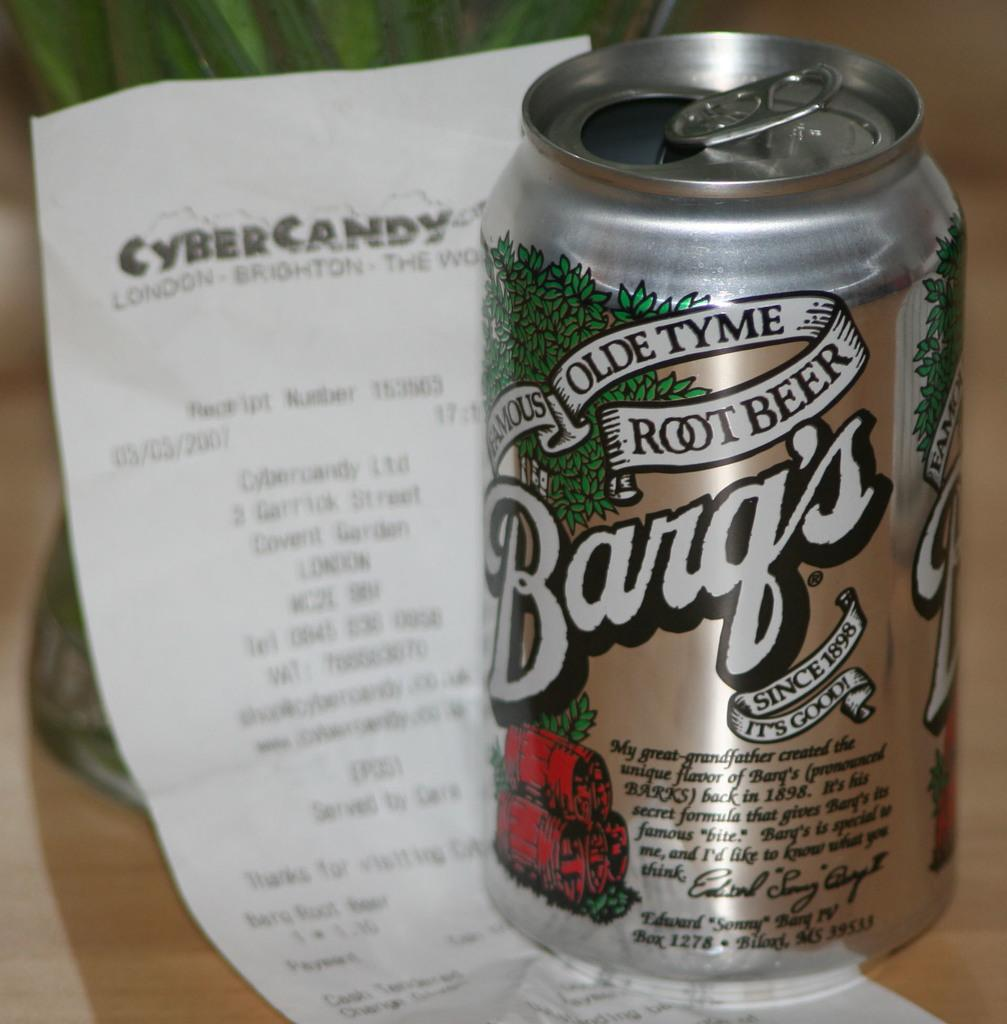<image>
Present a compact description of the photo's key features. A can of Barq's Olde Tyme Root Beer on top of a reciept. 